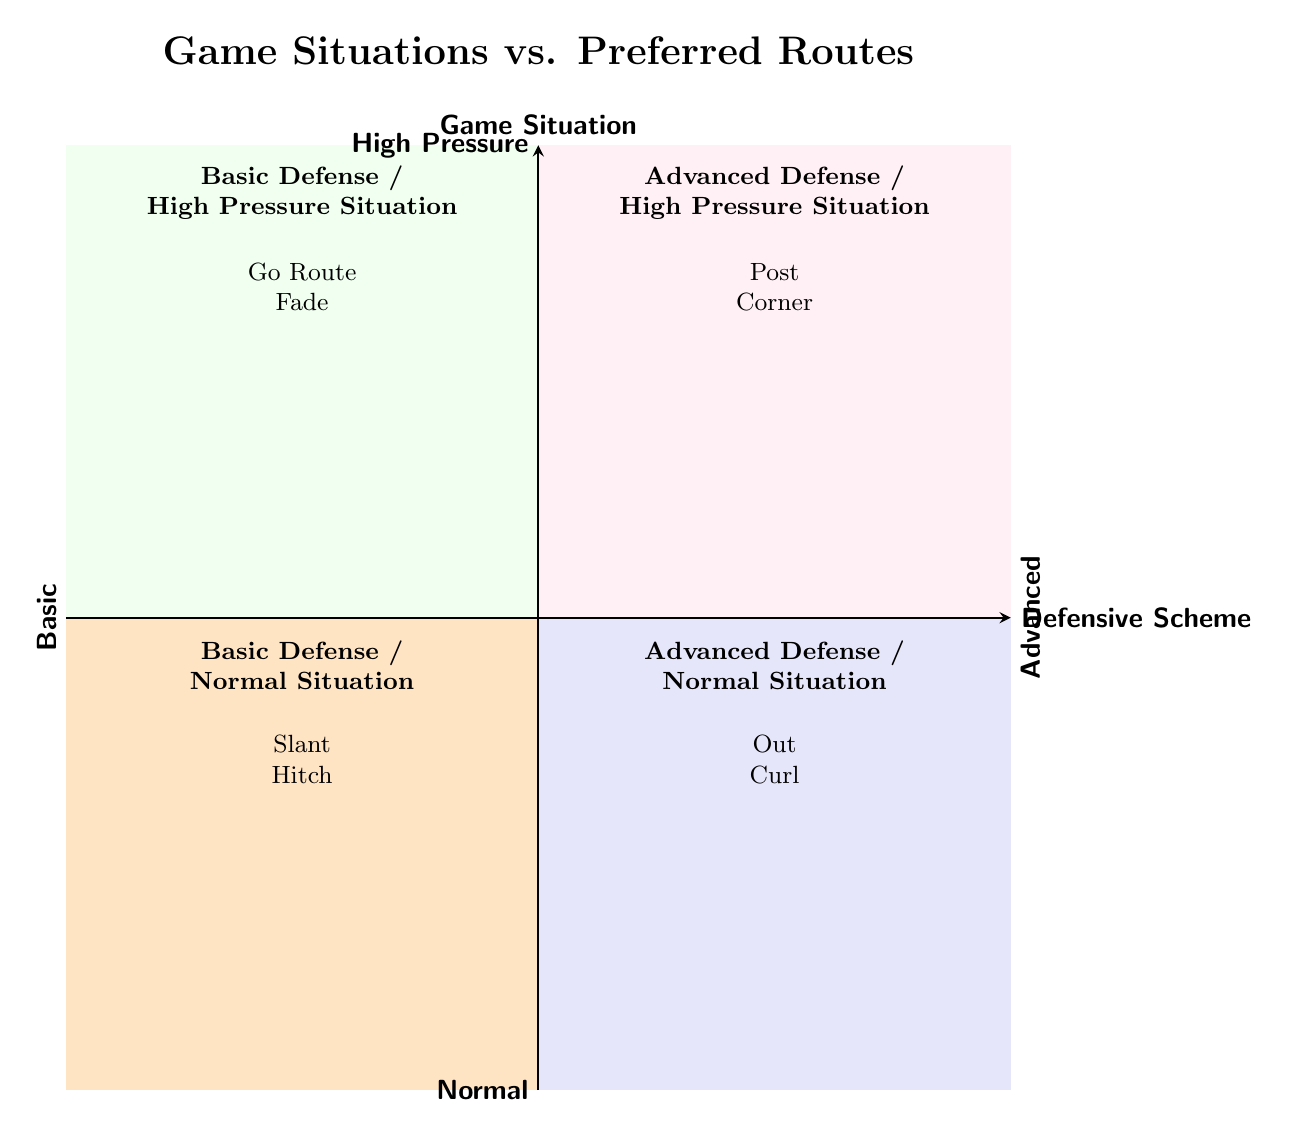What are the routes in the Basic Defense / Normal Situation? The Basic Defense / Normal Situation quadrant is located in the bottom left of the diagram, which shows two preferred routes: Slant and Hitch.
Answer: Slant, Hitch What are the routes associated with Advanced Defense / High Pressure Situation? The Advanced Defense / High Pressure Situation quadrant is in the top right segment of the diagram, featuring the routes Post and Corner.
Answer: Post, Corner Which quadrant contains the Go Route? The Go Route is found in the Basic Defense / High Pressure Situation quadrant, which is located in the top left part of the chart.
Answer: Top left How many routes are there in the Advanced Defense / Normal Situation? The Advanced Defense / Normal Situation quadrant has two routes listed: Out and Curl, so the total count is two.
Answer: 2 What type of situation is Slant associated with? The Slant route is associated with the Basic Defense / Normal Situation, located in the bottom left quadrant of the diagram.
Answer: Normal Situation In which quadrant would you expect to find routes for high-pressure situations? High-pressure situation routes are found in the top quadrants of the chart, including both Basic and Advanced Defense classifications.
Answer: Top quadrants Which route is preferred in a Basic Defense during a High Pressure Situation? The Go Route is preferred in the Basic Defense during High Pressure Situations, represented in the top left quadrant of the chart.
Answer: Go Route What are the two types of defensive schemes shown in the diagram? The diagram presents two defensive schemes, Basic and Advanced, as indicated in the labels on the X-axis.
Answer: Basic, Advanced What routes are preferred in the Advanced Defense / Normal Situation? The routes listed for the Advanced Defense / Normal Situation, located in the bottom right quadrant, are Out and Curl.
Answer: Out, Curl 